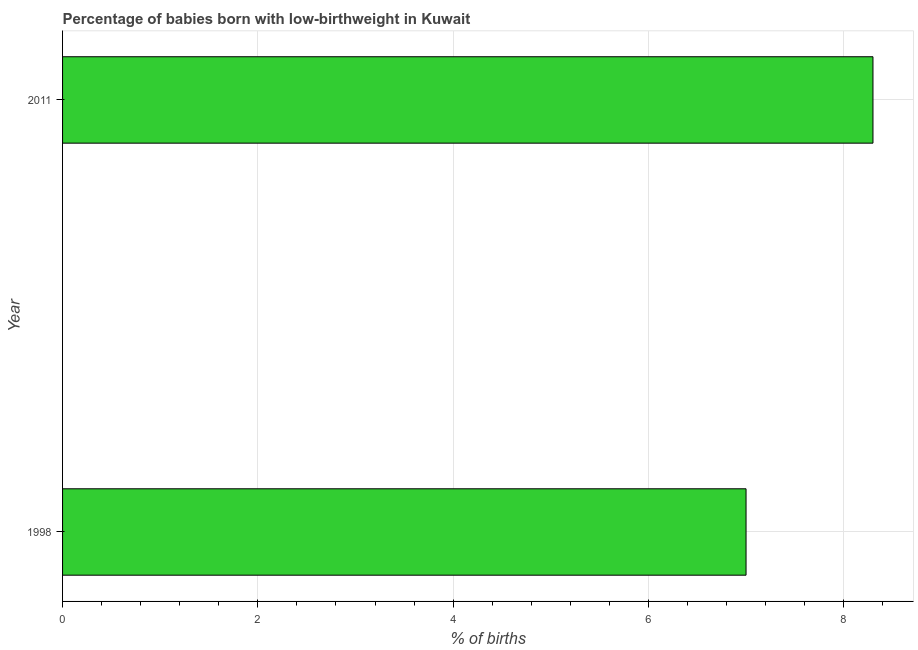Does the graph contain grids?
Your answer should be compact. Yes. What is the title of the graph?
Ensure brevity in your answer.  Percentage of babies born with low-birthweight in Kuwait. What is the label or title of the X-axis?
Ensure brevity in your answer.  % of births. Across all years, what is the maximum percentage of babies who were born with low-birthweight?
Make the answer very short. 8.3. What is the difference between the percentage of babies who were born with low-birthweight in 1998 and 2011?
Provide a short and direct response. -1.3. What is the average percentage of babies who were born with low-birthweight per year?
Offer a very short reply. 7.65. What is the median percentage of babies who were born with low-birthweight?
Your response must be concise. 7.65. Do a majority of the years between 1998 and 2011 (inclusive) have percentage of babies who were born with low-birthweight greater than 0.8 %?
Provide a short and direct response. Yes. What is the ratio of the percentage of babies who were born with low-birthweight in 1998 to that in 2011?
Your answer should be very brief. 0.84. Is the percentage of babies who were born with low-birthweight in 1998 less than that in 2011?
Offer a terse response. Yes. In how many years, is the percentage of babies who were born with low-birthweight greater than the average percentage of babies who were born with low-birthweight taken over all years?
Offer a terse response. 1. How many bars are there?
Your answer should be very brief. 2. Are all the bars in the graph horizontal?
Offer a terse response. Yes. What is the difference between two consecutive major ticks on the X-axis?
Provide a short and direct response. 2. What is the % of births of 1998?
Keep it short and to the point. 7. What is the difference between the % of births in 1998 and 2011?
Provide a succinct answer. -1.3. What is the ratio of the % of births in 1998 to that in 2011?
Keep it short and to the point. 0.84. 